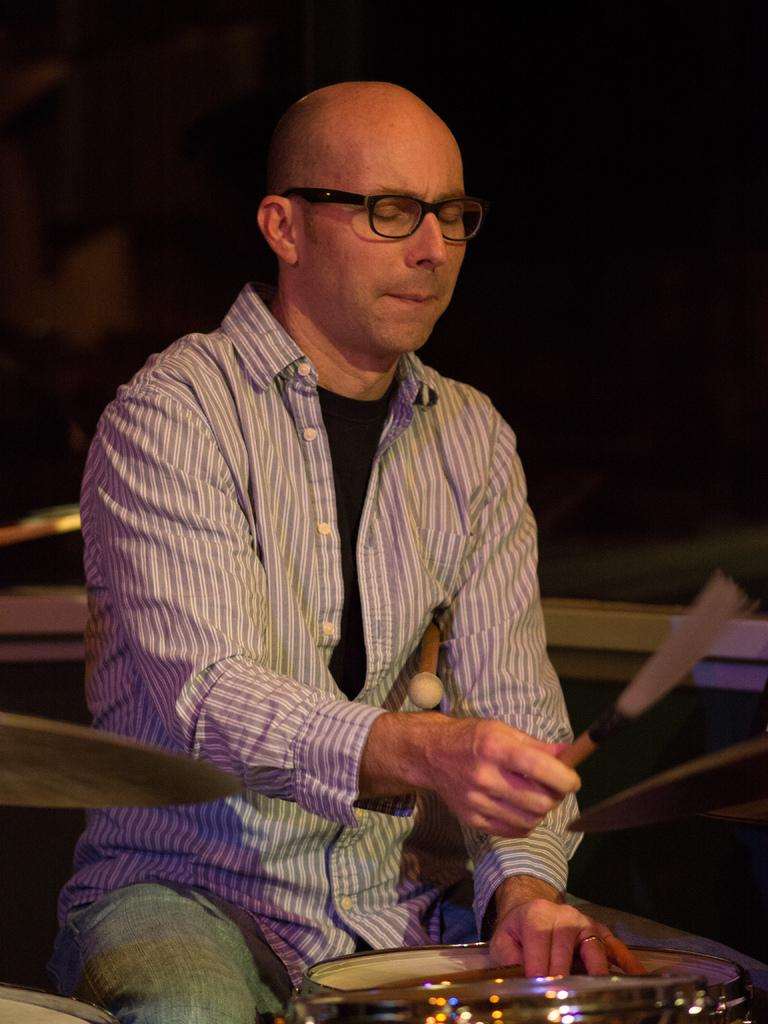What is the man in the image doing? The man is playing drums with sticks. What is the man wearing on his upper body? The man is wearing a linen shirt. Does the man have any accessories? Yes, the man has glasses (specs). What can be seen behind the man in the image? There are musical instruments behind the man. What type of scent can be detected from the man's linen shirt in the image? There is no information about the scent of the man's linen shirt in the image. Is the man wearing a boot on his left foot in the image? There is no information about the man's footwear in the image. 